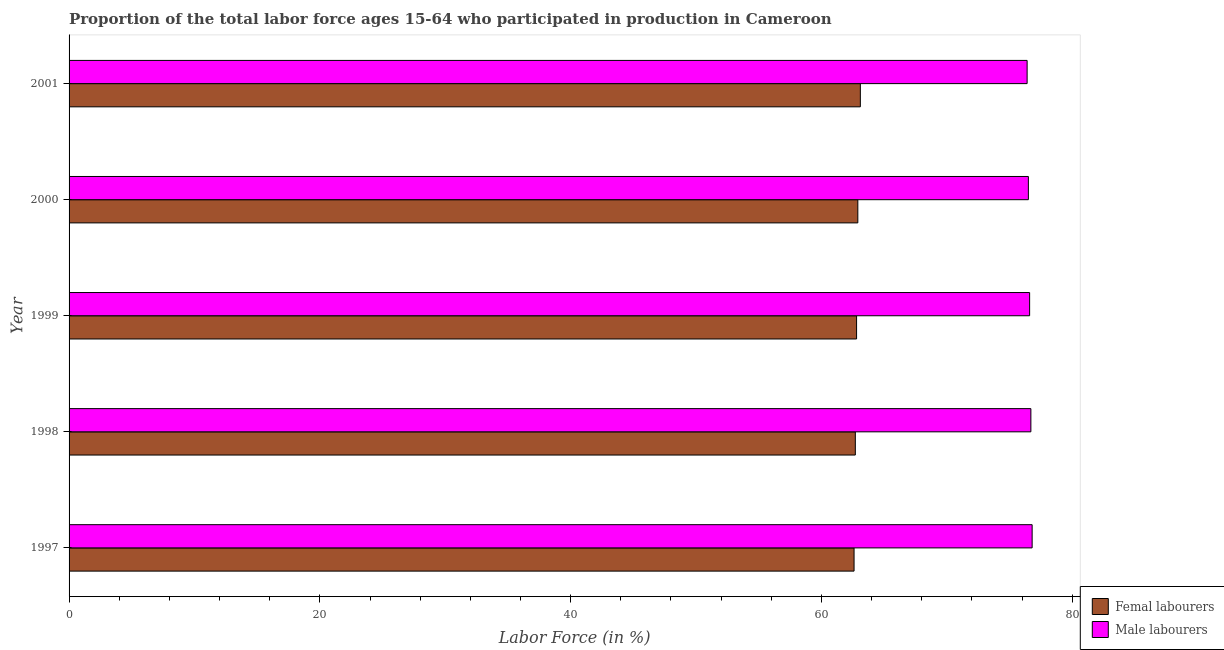How many different coloured bars are there?
Your answer should be compact. 2. How many groups of bars are there?
Offer a very short reply. 5. Are the number of bars per tick equal to the number of legend labels?
Keep it short and to the point. Yes. Are the number of bars on each tick of the Y-axis equal?
Give a very brief answer. Yes. What is the label of the 2nd group of bars from the top?
Make the answer very short. 2000. What is the percentage of male labour force in 1997?
Make the answer very short. 76.8. Across all years, what is the maximum percentage of male labour force?
Ensure brevity in your answer.  76.8. Across all years, what is the minimum percentage of male labour force?
Provide a succinct answer. 76.4. In which year was the percentage of female labor force maximum?
Your answer should be very brief. 2001. In which year was the percentage of female labor force minimum?
Offer a very short reply. 1997. What is the total percentage of female labor force in the graph?
Keep it short and to the point. 314.1. What is the difference between the percentage of female labor force in 1998 and the percentage of male labour force in 1999?
Make the answer very short. -13.9. What is the average percentage of female labor force per year?
Make the answer very short. 62.82. In the year 2000, what is the difference between the percentage of female labor force and percentage of male labour force?
Your response must be concise. -13.6. In how many years, is the percentage of female labor force greater than 4 %?
Provide a succinct answer. 5. What is the ratio of the percentage of female labor force in 1999 to that in 2000?
Your answer should be compact. 1. Is the percentage of female labor force in 1997 less than that in 2001?
Provide a succinct answer. Yes. What is the difference between the highest and the second highest percentage of female labor force?
Offer a very short reply. 0.2. What is the difference between the highest and the lowest percentage of male labour force?
Give a very brief answer. 0.4. In how many years, is the percentage of male labour force greater than the average percentage of male labour force taken over all years?
Give a very brief answer. 2. Is the sum of the percentage of female labor force in 1997 and 1999 greater than the maximum percentage of male labour force across all years?
Your response must be concise. Yes. What does the 1st bar from the top in 1998 represents?
Provide a short and direct response. Male labourers. What does the 2nd bar from the bottom in 1997 represents?
Offer a terse response. Male labourers. How many years are there in the graph?
Provide a short and direct response. 5. What is the difference between two consecutive major ticks on the X-axis?
Provide a short and direct response. 20. Are the values on the major ticks of X-axis written in scientific E-notation?
Your answer should be compact. No. Does the graph contain any zero values?
Your answer should be compact. No. What is the title of the graph?
Offer a very short reply. Proportion of the total labor force ages 15-64 who participated in production in Cameroon. What is the label or title of the X-axis?
Give a very brief answer. Labor Force (in %). What is the Labor Force (in %) in Femal labourers in 1997?
Your response must be concise. 62.6. What is the Labor Force (in %) of Male labourers in 1997?
Provide a short and direct response. 76.8. What is the Labor Force (in %) of Femal labourers in 1998?
Ensure brevity in your answer.  62.7. What is the Labor Force (in %) of Male labourers in 1998?
Provide a succinct answer. 76.7. What is the Labor Force (in %) of Femal labourers in 1999?
Your answer should be very brief. 62.8. What is the Labor Force (in %) in Male labourers in 1999?
Keep it short and to the point. 76.6. What is the Labor Force (in %) of Femal labourers in 2000?
Your answer should be compact. 62.9. What is the Labor Force (in %) of Male labourers in 2000?
Provide a succinct answer. 76.5. What is the Labor Force (in %) in Femal labourers in 2001?
Provide a short and direct response. 63.1. What is the Labor Force (in %) in Male labourers in 2001?
Your answer should be very brief. 76.4. Across all years, what is the maximum Labor Force (in %) in Femal labourers?
Ensure brevity in your answer.  63.1. Across all years, what is the maximum Labor Force (in %) in Male labourers?
Your response must be concise. 76.8. Across all years, what is the minimum Labor Force (in %) in Femal labourers?
Ensure brevity in your answer.  62.6. Across all years, what is the minimum Labor Force (in %) of Male labourers?
Ensure brevity in your answer.  76.4. What is the total Labor Force (in %) of Femal labourers in the graph?
Your answer should be compact. 314.1. What is the total Labor Force (in %) of Male labourers in the graph?
Your response must be concise. 383. What is the difference between the Labor Force (in %) of Femal labourers in 1997 and that in 2000?
Keep it short and to the point. -0.3. What is the difference between the Labor Force (in %) in Male labourers in 1997 and that in 2000?
Provide a short and direct response. 0.3. What is the difference between the Labor Force (in %) in Femal labourers in 1997 and that in 2001?
Offer a terse response. -0.5. What is the difference between the Labor Force (in %) in Male labourers in 1997 and that in 2001?
Provide a succinct answer. 0.4. What is the difference between the Labor Force (in %) in Male labourers in 1998 and that in 1999?
Keep it short and to the point. 0.1. What is the difference between the Labor Force (in %) in Male labourers in 1998 and that in 2000?
Your response must be concise. 0.2. What is the difference between the Labor Force (in %) of Male labourers in 1998 and that in 2001?
Keep it short and to the point. 0.3. What is the difference between the Labor Force (in %) in Femal labourers in 1999 and that in 2000?
Keep it short and to the point. -0.1. What is the difference between the Labor Force (in %) in Femal labourers in 1999 and that in 2001?
Provide a succinct answer. -0.3. What is the difference between the Labor Force (in %) of Femal labourers in 2000 and that in 2001?
Your response must be concise. -0.2. What is the difference between the Labor Force (in %) of Male labourers in 2000 and that in 2001?
Offer a very short reply. 0.1. What is the difference between the Labor Force (in %) in Femal labourers in 1997 and the Labor Force (in %) in Male labourers in 1998?
Provide a short and direct response. -14.1. What is the difference between the Labor Force (in %) of Femal labourers in 1997 and the Labor Force (in %) of Male labourers in 1999?
Offer a terse response. -14. What is the difference between the Labor Force (in %) in Femal labourers in 1997 and the Labor Force (in %) in Male labourers in 2000?
Provide a short and direct response. -13.9. What is the difference between the Labor Force (in %) of Femal labourers in 1997 and the Labor Force (in %) of Male labourers in 2001?
Your answer should be very brief. -13.8. What is the difference between the Labor Force (in %) of Femal labourers in 1998 and the Labor Force (in %) of Male labourers in 2001?
Offer a very short reply. -13.7. What is the difference between the Labor Force (in %) in Femal labourers in 1999 and the Labor Force (in %) in Male labourers in 2000?
Provide a short and direct response. -13.7. What is the difference between the Labor Force (in %) in Femal labourers in 2000 and the Labor Force (in %) in Male labourers in 2001?
Offer a very short reply. -13.5. What is the average Labor Force (in %) of Femal labourers per year?
Ensure brevity in your answer.  62.82. What is the average Labor Force (in %) of Male labourers per year?
Your response must be concise. 76.6. In the year 1998, what is the difference between the Labor Force (in %) of Femal labourers and Labor Force (in %) of Male labourers?
Your answer should be compact. -14. In the year 2000, what is the difference between the Labor Force (in %) in Femal labourers and Labor Force (in %) in Male labourers?
Offer a very short reply. -13.6. What is the ratio of the Labor Force (in %) of Male labourers in 1997 to that in 1998?
Give a very brief answer. 1. What is the ratio of the Labor Force (in %) of Femal labourers in 1997 to that in 2000?
Provide a short and direct response. 1. What is the ratio of the Labor Force (in %) in Male labourers in 1997 to that in 2000?
Your answer should be compact. 1. What is the ratio of the Labor Force (in %) of Male labourers in 1998 to that in 1999?
Offer a terse response. 1. What is the ratio of the Labor Force (in %) of Femal labourers in 1998 to that in 2000?
Make the answer very short. 1. What is the ratio of the Labor Force (in %) in Male labourers in 1998 to that in 2000?
Your response must be concise. 1. What is the ratio of the Labor Force (in %) of Femal labourers in 1998 to that in 2001?
Make the answer very short. 0.99. What is the ratio of the Labor Force (in %) of Male labourers in 1999 to that in 2001?
Give a very brief answer. 1. What is the ratio of the Labor Force (in %) in Femal labourers in 2000 to that in 2001?
Provide a short and direct response. 1. What is the ratio of the Labor Force (in %) of Male labourers in 2000 to that in 2001?
Keep it short and to the point. 1. What is the difference between the highest and the second highest Labor Force (in %) in Femal labourers?
Keep it short and to the point. 0.2. What is the difference between the highest and the lowest Labor Force (in %) in Femal labourers?
Your answer should be very brief. 0.5. What is the difference between the highest and the lowest Labor Force (in %) of Male labourers?
Your response must be concise. 0.4. 